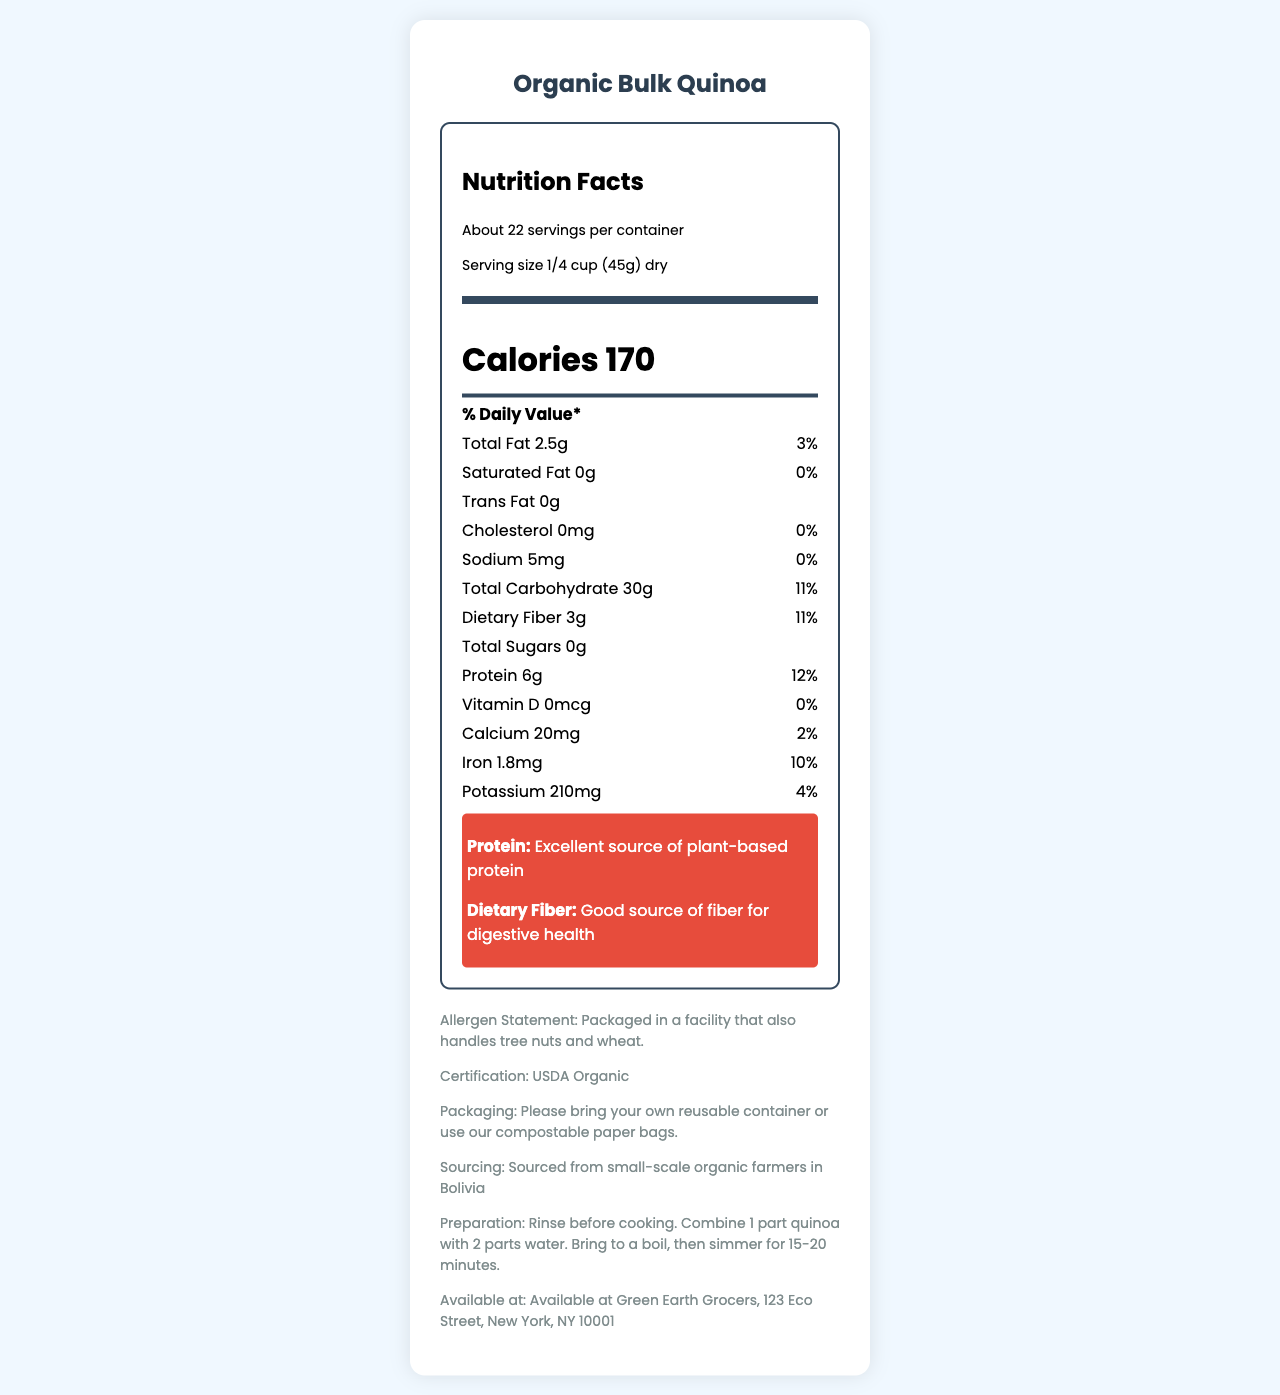what is the serving size of Organic Bulk Quinoa? The serving size is clearly mentioned under the serving information in the nutrition facts label as "Serving size 1/4 cup (45g) dry".
Answer: 1/4 cup (45g) dry how many calories are in one serving of the quinoa? The nutrition facts label states "Calories 170" prominently.
Answer: 170 is the quinoa a good source of dietary fiber? The nutrition label highlights Dietary Fiber with 3g and 11% of the daily value, indicating it is a good source of fiber.
Answer: Yes what percentage of the daily value for iron does one serving provide? The iron content is listed as 1.8mg which corresponds to 10% of the daily value.
Answer: 10% what is the total fat content per serving? The total fat content is listed in the nutrients section as "Total Fat 2.5g (3% Daily Value)".
Answer: 2.5g where is this Organic Bulk Quinoa sourced from? The document states "Sourced from small-scale organic farmers in Bolivia" in the additional information section.
Answer: Bolivia how much protein is there per serving, and why is it highlighted? Protein content is highlighted because it contains 6g per serving which is 12% of the daily value and is noted as an "excellent source of plant-based protein".
Answer: 6g how is the amount of total carbohydrate listed compared to the dietary fiber? In the nutrients section, total carbohydrate is 30g (11% Daily Value) whereas dietary fiber is 3g (11% Daily Value), making dietary fiber a subset of total carbohydrates.
Answer: Total Carbohydrate: 30g, Dietary Fiber: 3g which nutrient has the highest percent daily value? Among the listed nutrients, protein has the highest percent daily value at 12%.
Answer: Protein at 12% where can you find more quinoa if you like this product? The store information indicates that this product is available at Green Earth Grocers.
Answer: Green Earth Grocers, 123 Eco Street, New York, NY 10001 is this quinoa USDA organic certified? The additional information section confirms "USDA Organic" certification.
Answer: Yes does one serving of the quinoa contain any cholesterol? The document states "Cholesterol 0mg (0% Daily Value)", indicating no cholesterol.
Answer: No what should you bring to the store for packaging this organic quinoa? A. Plastic container B. Reusable container C. Glass jar D. Ziploc bag The zero-waste packaging instruction advises to "bring your own reusable container or use our compostable paper bags".
Answer: B which of the following nutrients is not present in this quinoa? I. Vitamin D II. Calcium III. Iron IV. Potassium The document shows Vitamin D as 0mcg (0% Daily Value) indicating it is not present in the quinoa.
Answer: I does the facility package any potential allergens? The allergen statement explicitly mentions "Packaged in a facility that also handles tree nuts and wheat".
Answer: Yes what is the main idea of this document? The document's main components include a nutrition label featuring calorie and nutrient content, additional pieces of information about the product's sourcing and certifications, and preparation and packaging guidelines.
Answer: The document provides nutritional facts, preparation instructions, and additional information about Organic Bulk Quinoa available at Green Earth Grocers. It highlights its protein and dietary fiber content, certifications, and zero-waste packaging instructions. how should you prepare this quinoa? The preparation instruction provided in the document specifies these steps for cooking the quinoa.
Answer: Rinse before cooking. Combine 1 part quinoa with 2 parts water. Bring to a boil, then simmer for 15-20 minutes. what other products are packaged in the same facility? The document states that tree nuts and wheat are handled in the same facility, but it does not specify what other products are packaged there.
Answer: Not enough information 